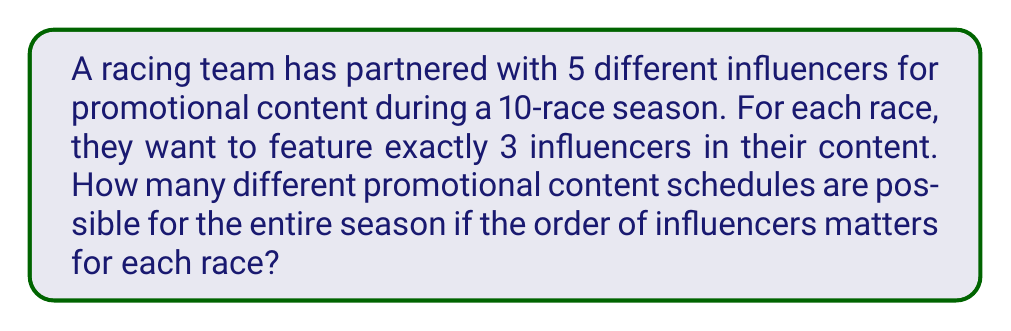Teach me how to tackle this problem. Let's approach this step-by-step:

1) For each race, we need to select 3 influencers out of 5, where the order matters. This is a permutation problem.

2) The number of ways to select 3 influencers out of 5, where order matters, is given by the permutation formula:
   $$P(5,3) = \frac{5!}{(5-3)!} = \frac{5!}{2!} = 60$$

3) This means for each individual race, there are 60 possible arrangements of influencers.

4) Now, we have 10 races in the season, and for each race, we make an independent choice from these 60 possibilities.

5) When we have a series of independent choices, we multiply the number of possibilities for each choice.

6) Therefore, the total number of different promotional content schedules for the entire season is:
   $$60^{10}$$

7) Calculating this:
   $$60^{10} = 60,466,176,000,000,000$$

This extremely large number represents all possible ways to arrange the influencers across all 10 races of the season.
Answer: $60^{10}$ 